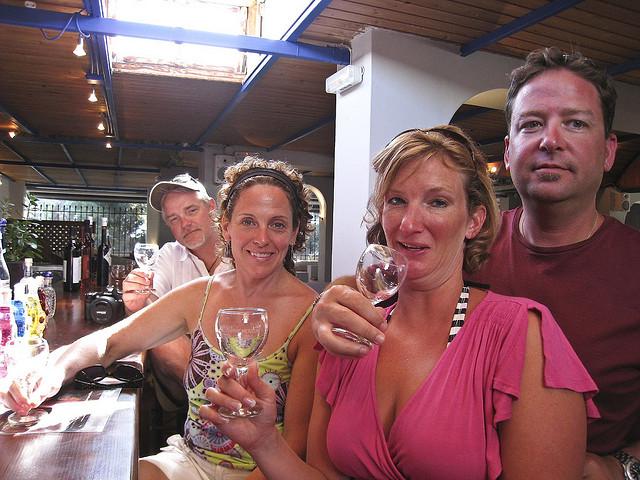Which woman has a headband?
Concise answer only. Left. What is the man on the left holding?
Keep it brief. Wine glass. Where are the wine glasses?
Be succinct. In their hands. How many people are wearing hats?
Concise answer only. 1. What is the woman in pink wearing under her shirt?
Quick response, please. Bathing suit. 